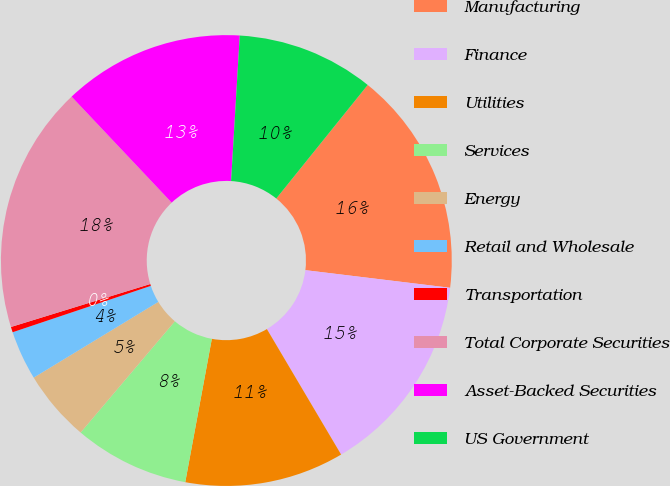Convert chart to OTSL. <chart><loc_0><loc_0><loc_500><loc_500><pie_chart><fcel>Manufacturing<fcel>Finance<fcel>Utilities<fcel>Services<fcel>Energy<fcel>Retail and Wholesale<fcel>Transportation<fcel>Total Corporate Securities<fcel>Asset-Backed Securities<fcel>US Government<nl><fcel>16.14%<fcel>14.57%<fcel>11.42%<fcel>8.27%<fcel>5.12%<fcel>3.54%<fcel>0.39%<fcel>17.72%<fcel>12.99%<fcel>9.84%<nl></chart> 